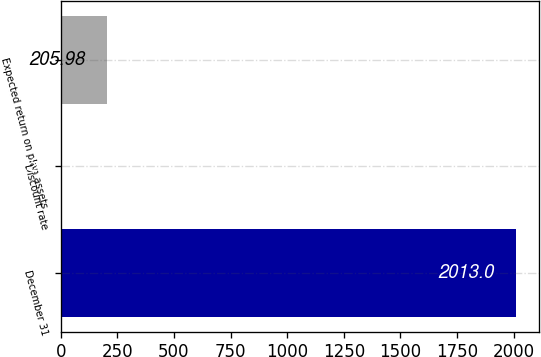<chart> <loc_0><loc_0><loc_500><loc_500><bar_chart><fcel>December 31<fcel>Discount rate<fcel>Expected return on plan assets<nl><fcel>2013<fcel>5.2<fcel>205.98<nl></chart> 